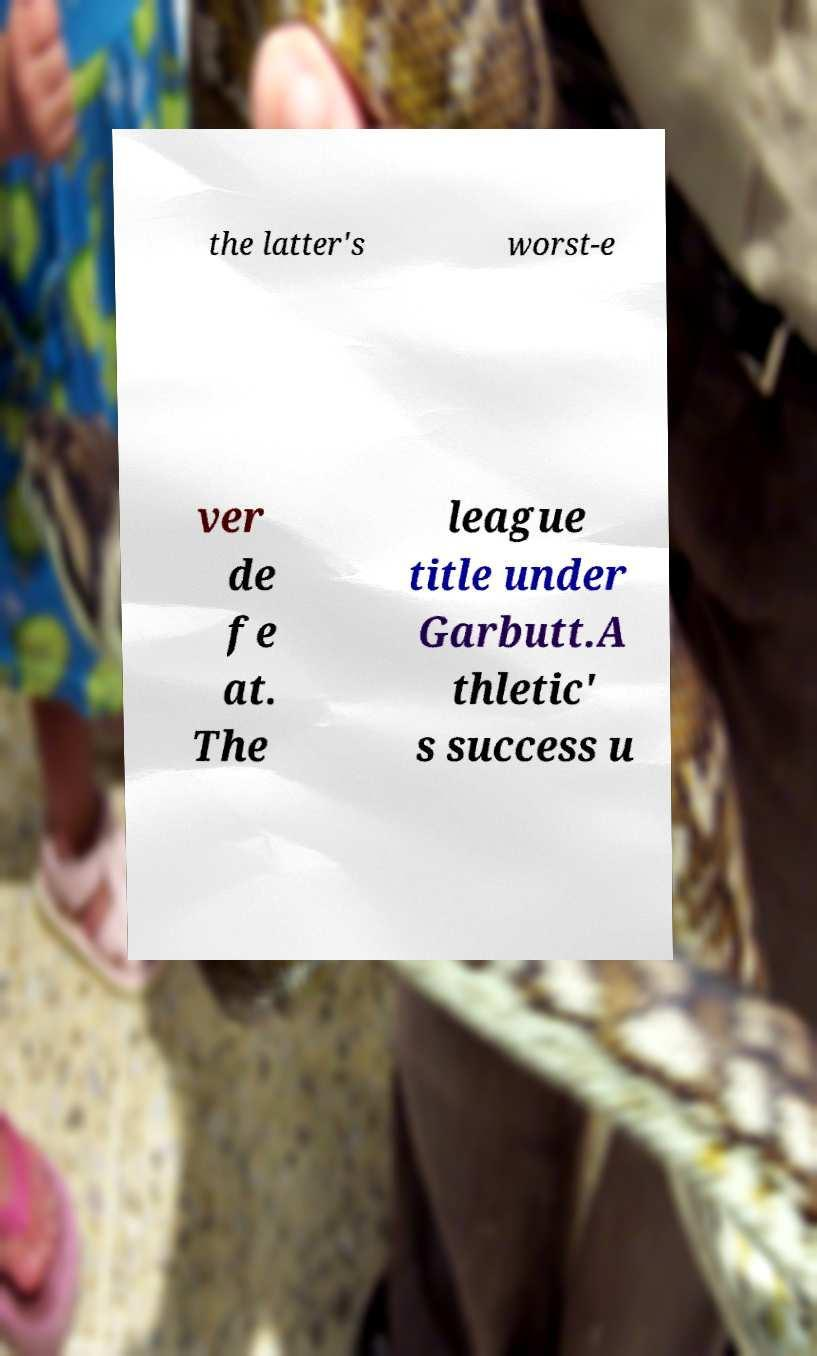Can you accurately transcribe the text from the provided image for me? the latter's worst-e ver de fe at. The league title under Garbutt.A thletic' s success u 